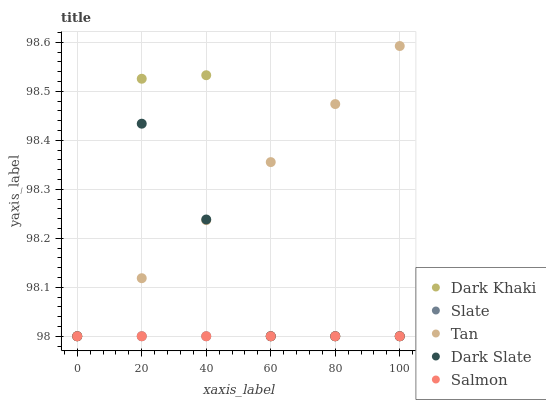Does Slate have the minimum area under the curve?
Answer yes or no. Yes. Does Tan have the maximum area under the curve?
Answer yes or no. Yes. Does Dark Slate have the minimum area under the curve?
Answer yes or no. No. Does Dark Slate have the maximum area under the curve?
Answer yes or no. No. Is Slate the smoothest?
Answer yes or no. Yes. Is Dark Khaki the roughest?
Answer yes or no. Yes. Is Dark Slate the smoothest?
Answer yes or no. No. Is Dark Slate the roughest?
Answer yes or no. No. Does Dark Khaki have the lowest value?
Answer yes or no. Yes. Does Tan have the highest value?
Answer yes or no. Yes. Does Dark Slate have the highest value?
Answer yes or no. No. Does Dark Slate intersect Dark Khaki?
Answer yes or no. Yes. Is Dark Slate less than Dark Khaki?
Answer yes or no. No. Is Dark Slate greater than Dark Khaki?
Answer yes or no. No. 